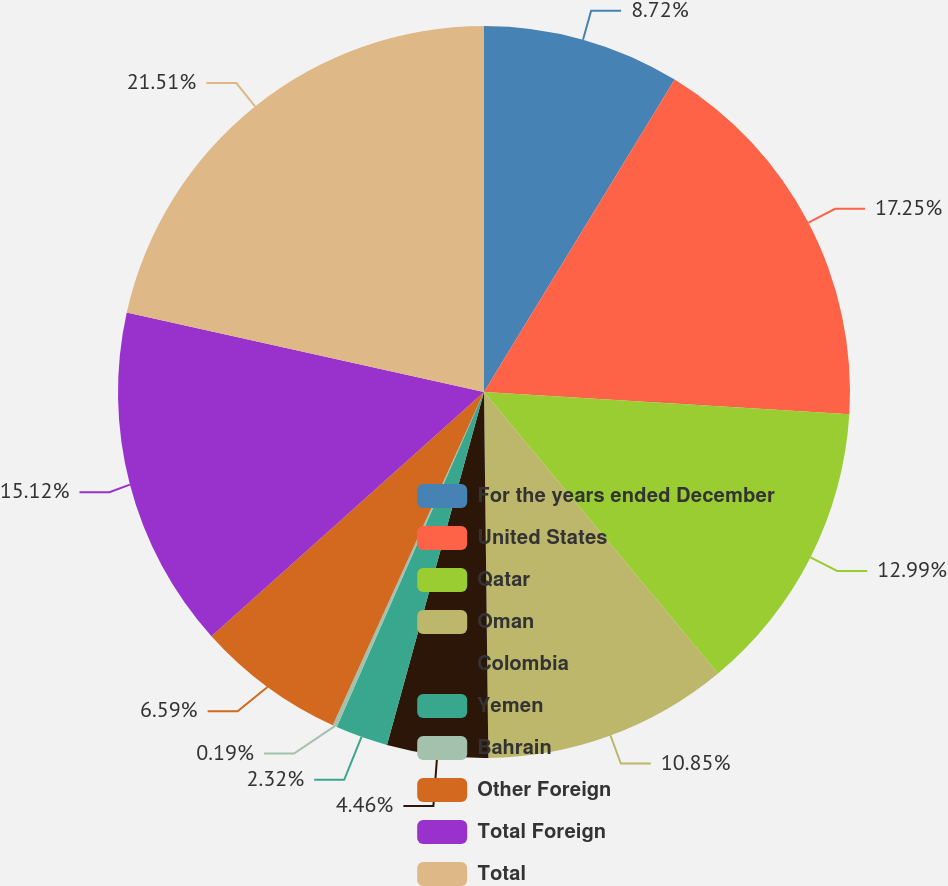Convert chart to OTSL. <chart><loc_0><loc_0><loc_500><loc_500><pie_chart><fcel>For the years ended December<fcel>United States<fcel>Qatar<fcel>Oman<fcel>Colombia<fcel>Yemen<fcel>Bahrain<fcel>Other Foreign<fcel>Total Foreign<fcel>Total<nl><fcel>8.72%<fcel>17.25%<fcel>12.99%<fcel>10.85%<fcel>4.46%<fcel>2.32%<fcel>0.19%<fcel>6.59%<fcel>15.12%<fcel>21.51%<nl></chart> 